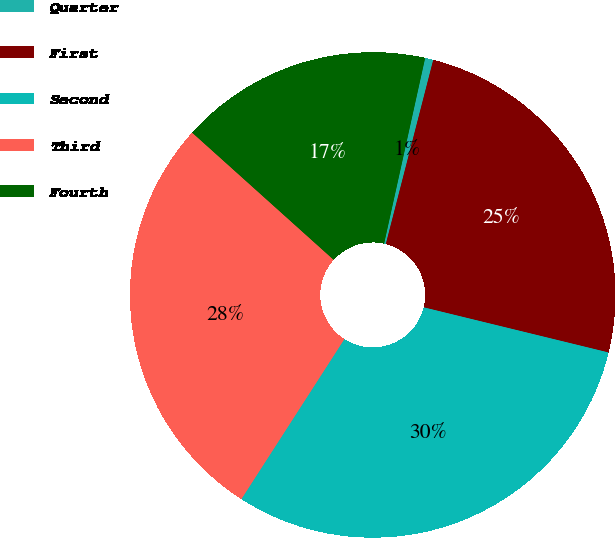Convert chart. <chart><loc_0><loc_0><loc_500><loc_500><pie_chart><fcel>Quarter<fcel>First<fcel>Second<fcel>Third<fcel>Fourth<nl><fcel>0.55%<fcel>24.8%<fcel>30.29%<fcel>27.55%<fcel>16.81%<nl></chart> 